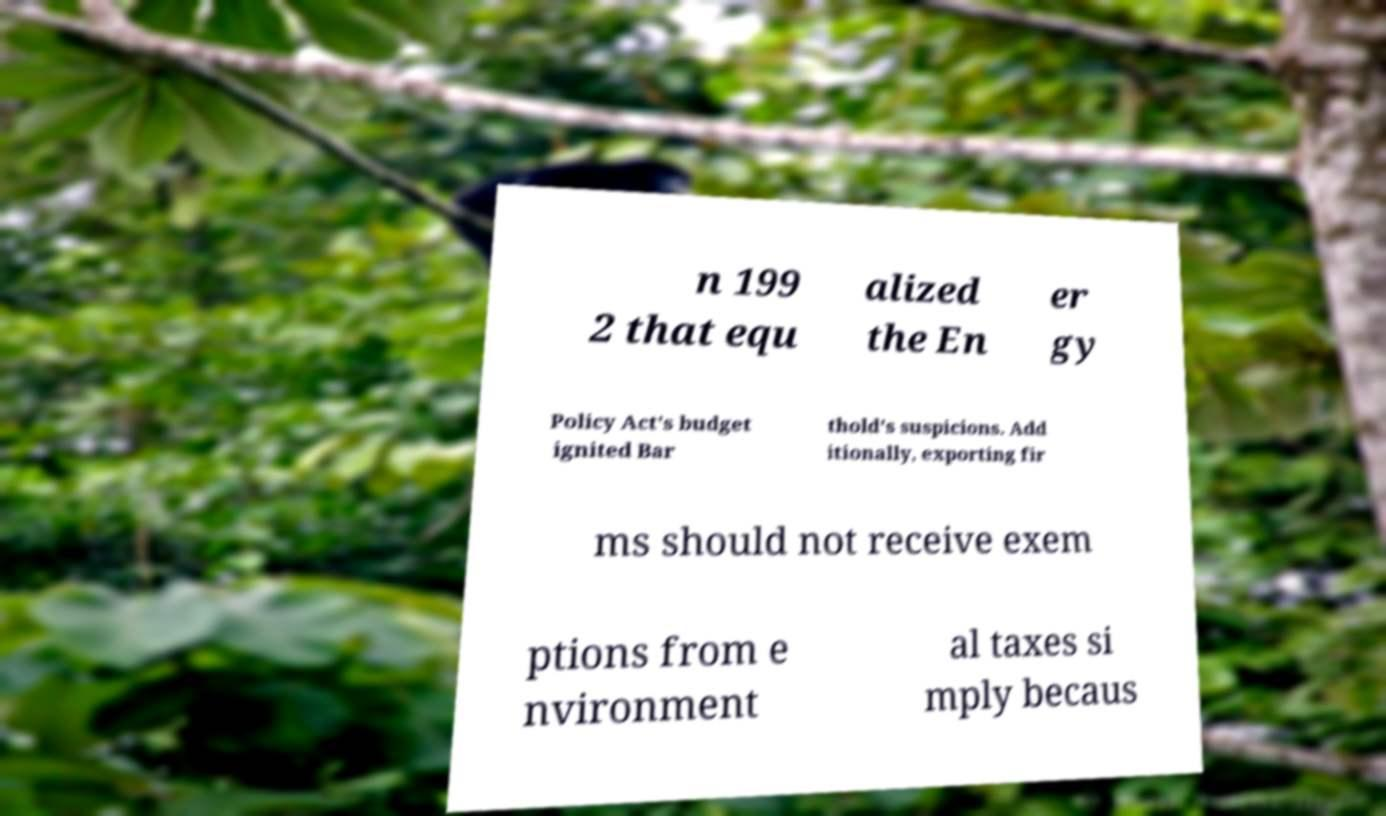I need the written content from this picture converted into text. Can you do that? n 199 2 that equ alized the En er gy Policy Act's budget ignited Bar thold's suspicions. Add itionally, exporting fir ms should not receive exem ptions from e nvironment al taxes si mply becaus 